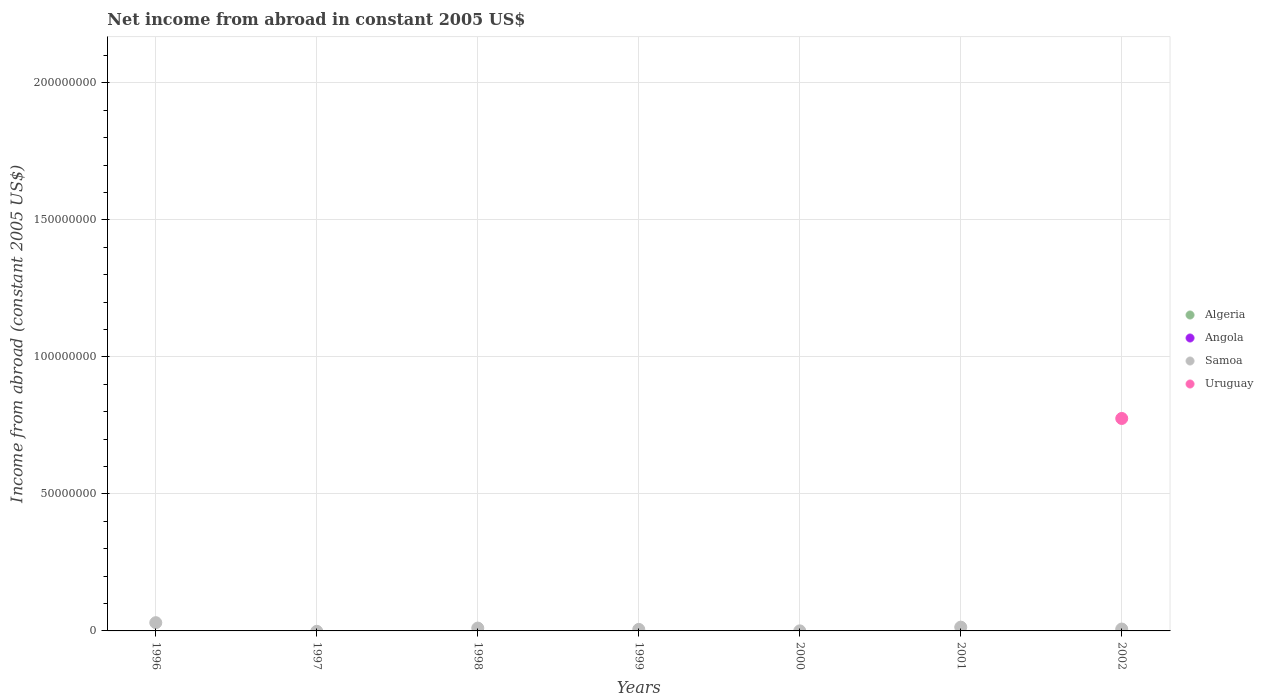How many different coloured dotlines are there?
Give a very brief answer. 2. What is the net income from abroad in Algeria in 2002?
Provide a succinct answer. 0. Across all years, what is the maximum net income from abroad in Uruguay?
Provide a succinct answer. 7.75e+07. In which year was the net income from abroad in Samoa maximum?
Offer a very short reply. 1996. What is the total net income from abroad in Samoa in the graph?
Your answer should be compact. 6.69e+06. What is the difference between the net income from abroad in Samoa in 2000 and that in 2002?
Keep it short and to the point. -6.69e+05. What is the average net income from abroad in Uruguay per year?
Ensure brevity in your answer.  1.11e+07. What is the ratio of the net income from abroad in Samoa in 1996 to that in 1998?
Your answer should be compact. 2.9. What is the difference between the highest and the second highest net income from abroad in Samoa?
Offer a terse response. 1.63e+06. What is the difference between the highest and the lowest net income from abroad in Samoa?
Your answer should be compact. 3.01e+06. In how many years, is the net income from abroad in Uruguay greater than the average net income from abroad in Uruguay taken over all years?
Your response must be concise. 1. Does the net income from abroad in Samoa monotonically increase over the years?
Give a very brief answer. No. How many years are there in the graph?
Make the answer very short. 7. What is the difference between two consecutive major ticks on the Y-axis?
Give a very brief answer. 5.00e+07. Are the values on the major ticks of Y-axis written in scientific E-notation?
Ensure brevity in your answer.  No. Does the graph contain any zero values?
Make the answer very short. Yes. How are the legend labels stacked?
Give a very brief answer. Vertical. What is the title of the graph?
Give a very brief answer. Net income from abroad in constant 2005 US$. Does "Brunei Darussalam" appear as one of the legend labels in the graph?
Offer a very short reply. No. What is the label or title of the Y-axis?
Offer a terse response. Income from abroad (constant 2005 US$). What is the Income from abroad (constant 2005 US$) in Algeria in 1996?
Your response must be concise. 0. What is the Income from abroad (constant 2005 US$) in Samoa in 1996?
Keep it short and to the point. 3.01e+06. What is the Income from abroad (constant 2005 US$) in Uruguay in 1996?
Your answer should be very brief. 0. What is the Income from abroad (constant 2005 US$) in Uruguay in 1997?
Keep it short and to the point. 0. What is the Income from abroad (constant 2005 US$) in Algeria in 1998?
Your answer should be very brief. 0. What is the Income from abroad (constant 2005 US$) of Angola in 1998?
Keep it short and to the point. 0. What is the Income from abroad (constant 2005 US$) of Samoa in 1998?
Give a very brief answer. 1.04e+06. What is the Income from abroad (constant 2005 US$) in Uruguay in 1998?
Your answer should be compact. 0. What is the Income from abroad (constant 2005 US$) in Samoa in 1999?
Offer a very short reply. 5.57e+05. What is the Income from abroad (constant 2005 US$) of Uruguay in 1999?
Provide a short and direct response. 0. What is the Income from abroad (constant 2005 US$) in Algeria in 2000?
Provide a succinct answer. 0. What is the Income from abroad (constant 2005 US$) in Samoa in 2000?
Keep it short and to the point. 1.89e+04. What is the Income from abroad (constant 2005 US$) of Uruguay in 2000?
Offer a terse response. 0. What is the Income from abroad (constant 2005 US$) in Algeria in 2001?
Your answer should be very brief. 0. What is the Income from abroad (constant 2005 US$) of Samoa in 2001?
Ensure brevity in your answer.  1.38e+06. What is the Income from abroad (constant 2005 US$) in Samoa in 2002?
Provide a succinct answer. 6.88e+05. What is the Income from abroad (constant 2005 US$) in Uruguay in 2002?
Provide a succinct answer. 7.75e+07. Across all years, what is the maximum Income from abroad (constant 2005 US$) of Samoa?
Your response must be concise. 3.01e+06. Across all years, what is the maximum Income from abroad (constant 2005 US$) of Uruguay?
Offer a terse response. 7.75e+07. Across all years, what is the minimum Income from abroad (constant 2005 US$) of Samoa?
Ensure brevity in your answer.  0. What is the total Income from abroad (constant 2005 US$) of Angola in the graph?
Provide a short and direct response. 0. What is the total Income from abroad (constant 2005 US$) of Samoa in the graph?
Offer a very short reply. 6.69e+06. What is the total Income from abroad (constant 2005 US$) in Uruguay in the graph?
Provide a short and direct response. 7.75e+07. What is the difference between the Income from abroad (constant 2005 US$) in Samoa in 1996 and that in 1998?
Provide a succinct answer. 1.97e+06. What is the difference between the Income from abroad (constant 2005 US$) of Samoa in 1996 and that in 1999?
Provide a short and direct response. 2.45e+06. What is the difference between the Income from abroad (constant 2005 US$) of Samoa in 1996 and that in 2000?
Keep it short and to the point. 2.99e+06. What is the difference between the Income from abroad (constant 2005 US$) in Samoa in 1996 and that in 2001?
Give a very brief answer. 1.63e+06. What is the difference between the Income from abroad (constant 2005 US$) of Samoa in 1996 and that in 2002?
Keep it short and to the point. 2.32e+06. What is the difference between the Income from abroad (constant 2005 US$) in Samoa in 1998 and that in 1999?
Your response must be concise. 4.80e+05. What is the difference between the Income from abroad (constant 2005 US$) in Samoa in 1998 and that in 2000?
Make the answer very short. 1.02e+06. What is the difference between the Income from abroad (constant 2005 US$) of Samoa in 1998 and that in 2001?
Provide a succinct answer. -3.44e+05. What is the difference between the Income from abroad (constant 2005 US$) in Samoa in 1998 and that in 2002?
Make the answer very short. 3.48e+05. What is the difference between the Income from abroad (constant 2005 US$) of Samoa in 1999 and that in 2000?
Provide a short and direct response. 5.38e+05. What is the difference between the Income from abroad (constant 2005 US$) of Samoa in 1999 and that in 2001?
Your response must be concise. -8.24e+05. What is the difference between the Income from abroad (constant 2005 US$) in Samoa in 1999 and that in 2002?
Your response must be concise. -1.32e+05. What is the difference between the Income from abroad (constant 2005 US$) in Samoa in 2000 and that in 2001?
Your response must be concise. -1.36e+06. What is the difference between the Income from abroad (constant 2005 US$) in Samoa in 2000 and that in 2002?
Provide a succinct answer. -6.69e+05. What is the difference between the Income from abroad (constant 2005 US$) of Samoa in 2001 and that in 2002?
Your response must be concise. 6.92e+05. What is the difference between the Income from abroad (constant 2005 US$) in Samoa in 1996 and the Income from abroad (constant 2005 US$) in Uruguay in 2002?
Provide a succinct answer. -7.45e+07. What is the difference between the Income from abroad (constant 2005 US$) of Samoa in 1998 and the Income from abroad (constant 2005 US$) of Uruguay in 2002?
Give a very brief answer. -7.65e+07. What is the difference between the Income from abroad (constant 2005 US$) of Samoa in 1999 and the Income from abroad (constant 2005 US$) of Uruguay in 2002?
Keep it short and to the point. -7.70e+07. What is the difference between the Income from abroad (constant 2005 US$) in Samoa in 2000 and the Income from abroad (constant 2005 US$) in Uruguay in 2002?
Your response must be concise. -7.75e+07. What is the difference between the Income from abroad (constant 2005 US$) in Samoa in 2001 and the Income from abroad (constant 2005 US$) in Uruguay in 2002?
Offer a terse response. -7.62e+07. What is the average Income from abroad (constant 2005 US$) in Samoa per year?
Provide a succinct answer. 9.55e+05. What is the average Income from abroad (constant 2005 US$) of Uruguay per year?
Make the answer very short. 1.11e+07. In the year 2002, what is the difference between the Income from abroad (constant 2005 US$) in Samoa and Income from abroad (constant 2005 US$) in Uruguay?
Ensure brevity in your answer.  -7.68e+07. What is the ratio of the Income from abroad (constant 2005 US$) of Samoa in 1996 to that in 1998?
Provide a short and direct response. 2.9. What is the ratio of the Income from abroad (constant 2005 US$) in Samoa in 1996 to that in 1999?
Make the answer very short. 5.4. What is the ratio of the Income from abroad (constant 2005 US$) in Samoa in 1996 to that in 2000?
Offer a very short reply. 159.13. What is the ratio of the Income from abroad (constant 2005 US$) of Samoa in 1996 to that in 2001?
Ensure brevity in your answer.  2.18. What is the ratio of the Income from abroad (constant 2005 US$) in Samoa in 1996 to that in 2002?
Give a very brief answer. 4.37. What is the ratio of the Income from abroad (constant 2005 US$) in Samoa in 1998 to that in 1999?
Provide a short and direct response. 1.86. What is the ratio of the Income from abroad (constant 2005 US$) of Samoa in 1998 to that in 2000?
Provide a short and direct response. 54.87. What is the ratio of the Income from abroad (constant 2005 US$) in Samoa in 1998 to that in 2001?
Offer a very short reply. 0.75. What is the ratio of the Income from abroad (constant 2005 US$) in Samoa in 1998 to that in 2002?
Keep it short and to the point. 1.51. What is the ratio of the Income from abroad (constant 2005 US$) in Samoa in 1999 to that in 2000?
Offer a terse response. 29.46. What is the ratio of the Income from abroad (constant 2005 US$) in Samoa in 1999 to that in 2001?
Offer a very short reply. 0.4. What is the ratio of the Income from abroad (constant 2005 US$) of Samoa in 1999 to that in 2002?
Your response must be concise. 0.81. What is the ratio of the Income from abroad (constant 2005 US$) in Samoa in 2000 to that in 2001?
Your answer should be compact. 0.01. What is the ratio of the Income from abroad (constant 2005 US$) of Samoa in 2000 to that in 2002?
Provide a succinct answer. 0.03. What is the ratio of the Income from abroad (constant 2005 US$) in Samoa in 2001 to that in 2002?
Give a very brief answer. 2.01. What is the difference between the highest and the second highest Income from abroad (constant 2005 US$) in Samoa?
Your answer should be compact. 1.63e+06. What is the difference between the highest and the lowest Income from abroad (constant 2005 US$) of Samoa?
Ensure brevity in your answer.  3.01e+06. What is the difference between the highest and the lowest Income from abroad (constant 2005 US$) in Uruguay?
Offer a terse response. 7.75e+07. 